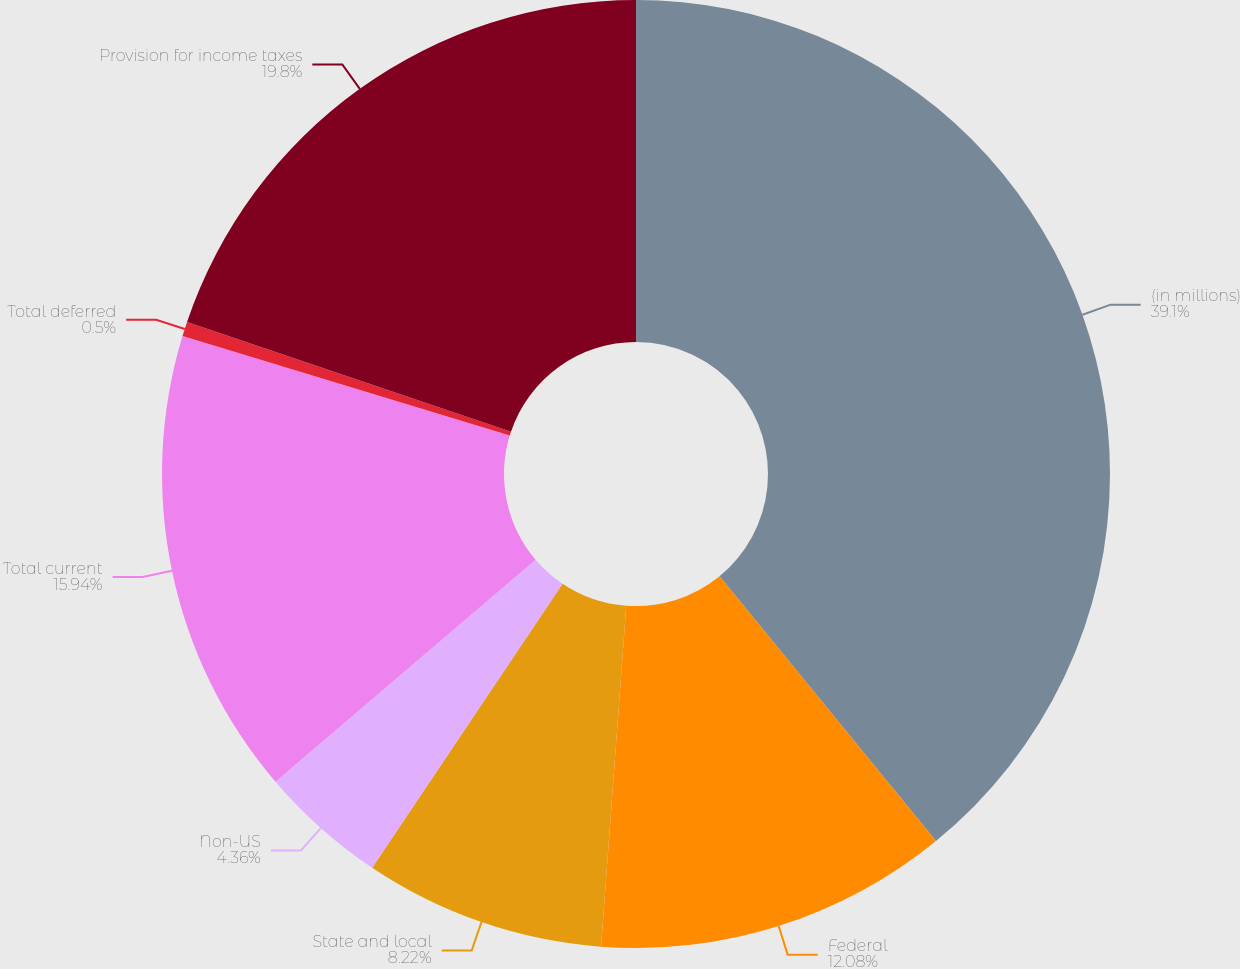Convert chart. <chart><loc_0><loc_0><loc_500><loc_500><pie_chart><fcel>(in millions)<fcel>Federal<fcel>State and local<fcel>Non-US<fcel>Total current<fcel>Total deferred<fcel>Provision for income taxes<nl><fcel>39.09%<fcel>12.08%<fcel>8.22%<fcel>4.36%<fcel>15.94%<fcel>0.5%<fcel>19.8%<nl></chart> 